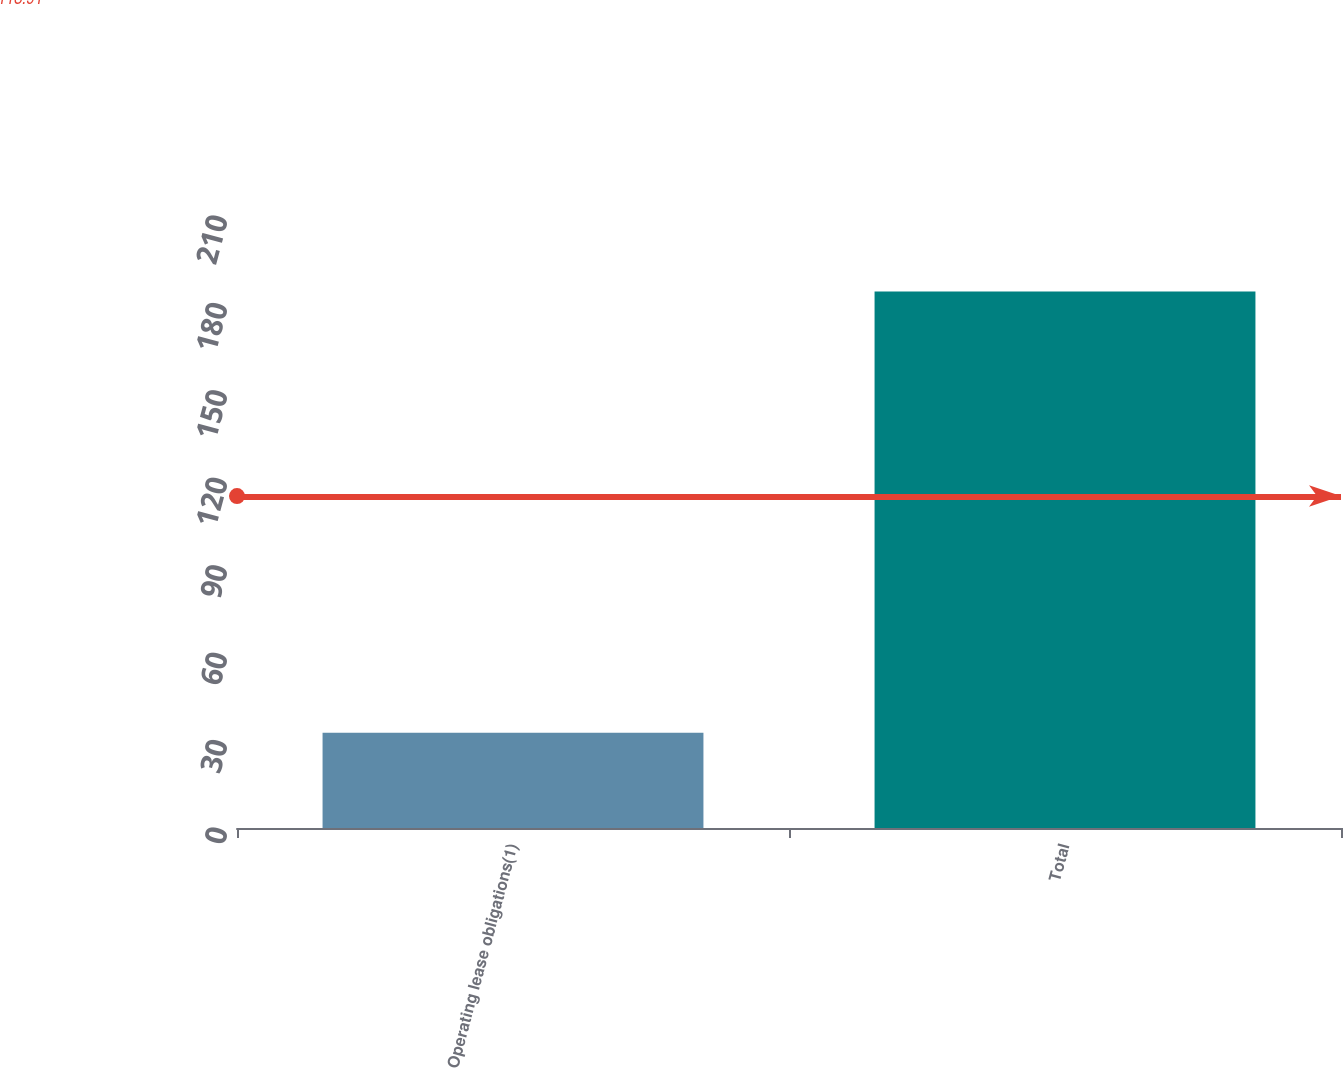Convert chart to OTSL. <chart><loc_0><loc_0><loc_500><loc_500><bar_chart><fcel>Operating lease obligations(1)<fcel>Total<nl><fcel>32.7<fcel>184.1<nl></chart> 